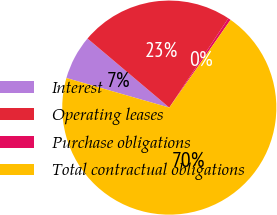Convert chart to OTSL. <chart><loc_0><loc_0><loc_500><loc_500><pie_chart><fcel>Interest<fcel>Operating leases<fcel>Purchase obligations<fcel>Total contractual obligations<nl><fcel>6.71%<fcel>23.13%<fcel>0.41%<fcel>69.75%<nl></chart> 